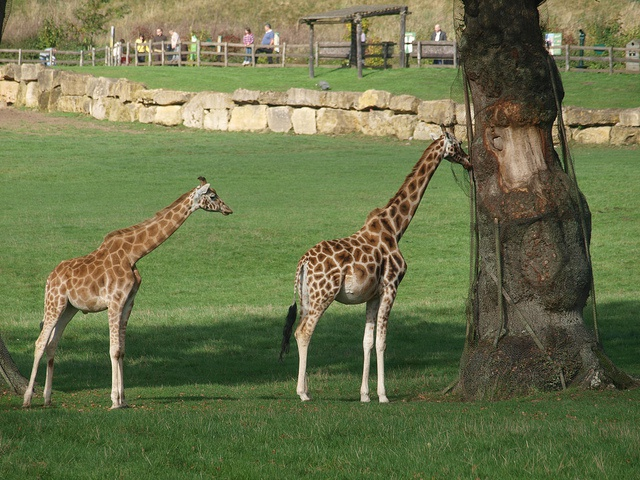Describe the objects in this image and their specific colors. I can see giraffe in black, maroon, and tan tones, giraffe in black, tan, gray, and brown tones, people in black, darkgray, and gray tones, people in black, darkgray, lightpink, and gray tones, and people in black, darkgray, lightgray, gray, and tan tones in this image. 